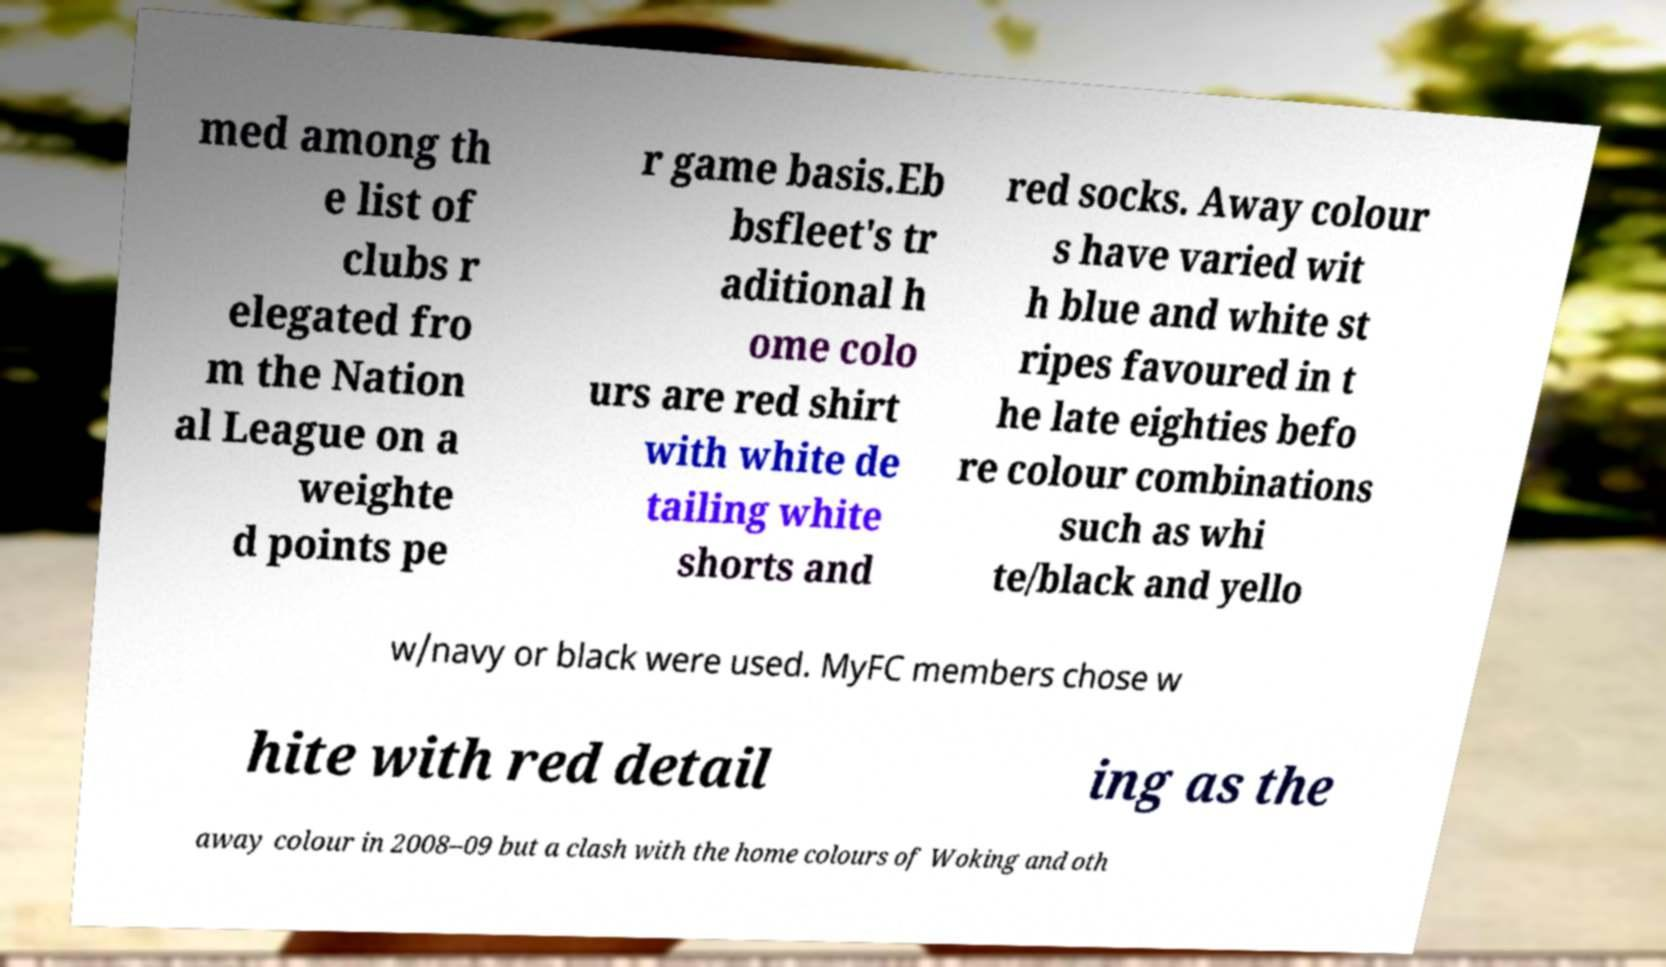Could you assist in decoding the text presented in this image and type it out clearly? med among th e list of clubs r elegated fro m the Nation al League on a weighte d points pe r game basis.Eb bsfleet's tr aditional h ome colo urs are red shirt with white de tailing white shorts and red socks. Away colour s have varied wit h blue and white st ripes favoured in t he late eighties befo re colour combinations such as whi te/black and yello w/navy or black were used. MyFC members chose w hite with red detail ing as the away colour in 2008–09 but a clash with the home colours of Woking and oth 